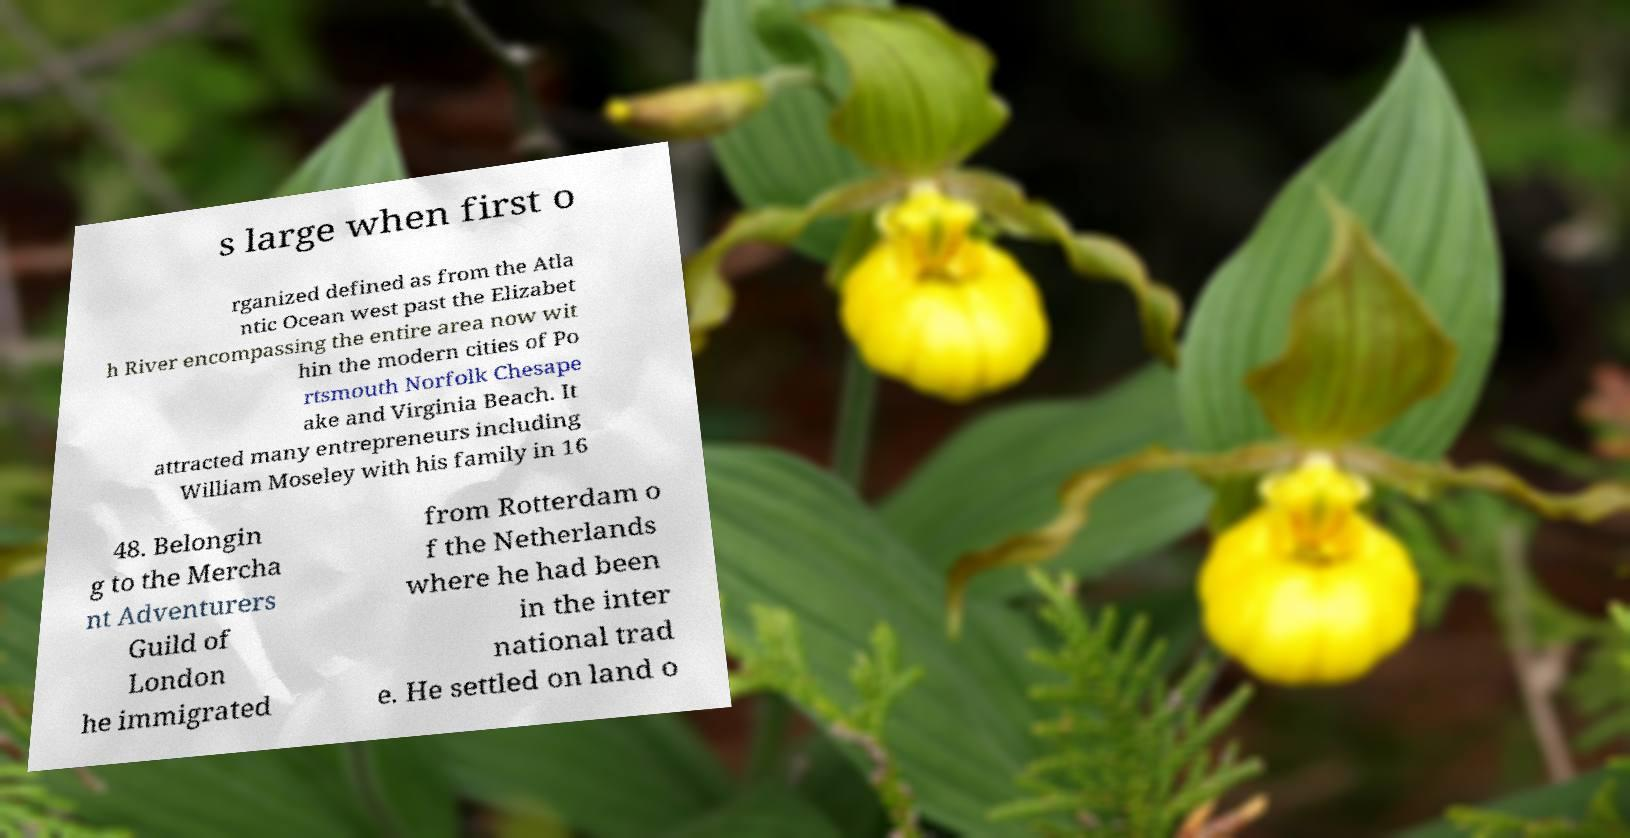Please identify and transcribe the text found in this image. s large when first o rganized defined as from the Atla ntic Ocean west past the Elizabet h River encompassing the entire area now wit hin the modern cities of Po rtsmouth Norfolk Chesape ake and Virginia Beach. It attracted many entrepreneurs including William Moseley with his family in 16 48. Belongin g to the Mercha nt Adventurers Guild of London he immigrated from Rotterdam o f the Netherlands where he had been in the inter national trad e. He settled on land o 